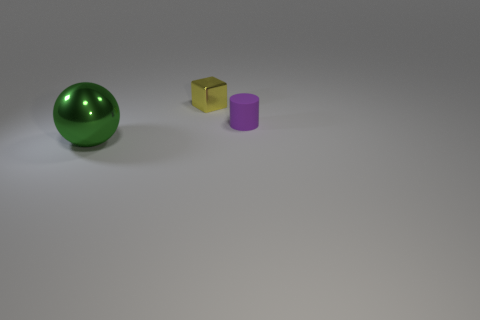Add 3 tiny purple matte things. How many objects exist? 6 Subtract all spheres. How many objects are left? 2 Subtract all gray spheres. Subtract all green shiny balls. How many objects are left? 2 Add 3 tiny purple things. How many tiny purple things are left? 4 Add 3 gray rubber cylinders. How many gray rubber cylinders exist? 3 Subtract 1 purple cylinders. How many objects are left? 2 